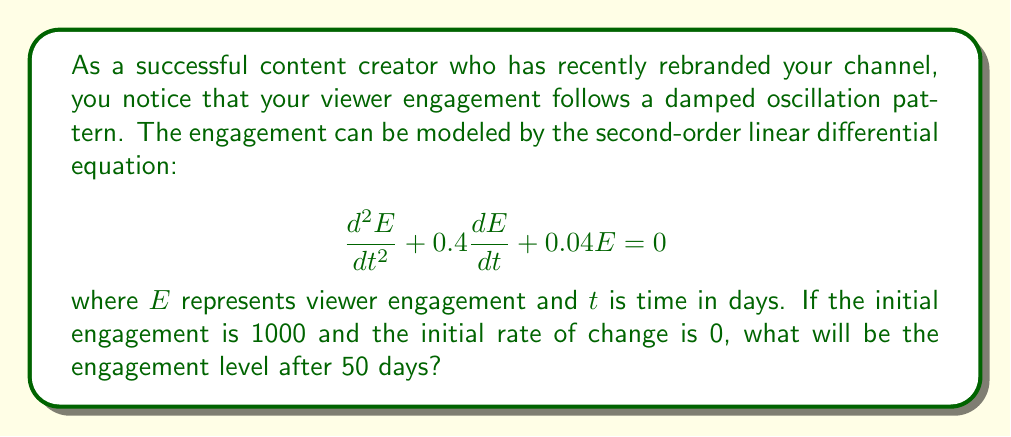Help me with this question. To solve this problem, we need to follow these steps:

1) The characteristic equation for this differential equation is:
   $$r^2 + 0.4r + 0.04 = 0$$

2) Solving this quadratic equation:
   $$r = \frac{-0.4 \pm \sqrt{0.4^2 - 4(1)(0.04)}}{2(1)} = \frac{-0.4 \pm \sqrt{0.16 - 0.16}}{2} = -0.2$$

3) Since we have a repeated root, the general solution is:
   $$E(t) = (C_1 + C_2t)e^{-0.2t}$$

4) Given initial conditions: $E(0) = 1000$ and $E'(0) = 0$

5) Applying the first condition:
   $$E(0) = C_1 = 1000$$

6) Taking the derivative of the general solution:
   $$E'(t) = (-0.2C_1 - 0.2C_2t + C_2)e^{-0.2t}$$

7) Applying the second condition:
   $$E'(0) = -0.2C_1 + C_2 = 0$$
   $$C_2 = 0.2C_1 = 0.2(1000) = 200$$

8) Therefore, the particular solution is:
   $$E(t) = (1000 + 200t)e^{-0.2t}$$

9) To find engagement after 50 days, substitute $t = 50$:
   $$E(50) = (1000 + 200(50))e^{-0.2(50)}$$
   $$= 11000e^{-10}$$
   $$\approx 16.81$$
Answer: The engagement level after 50 days will be approximately 16.81. 